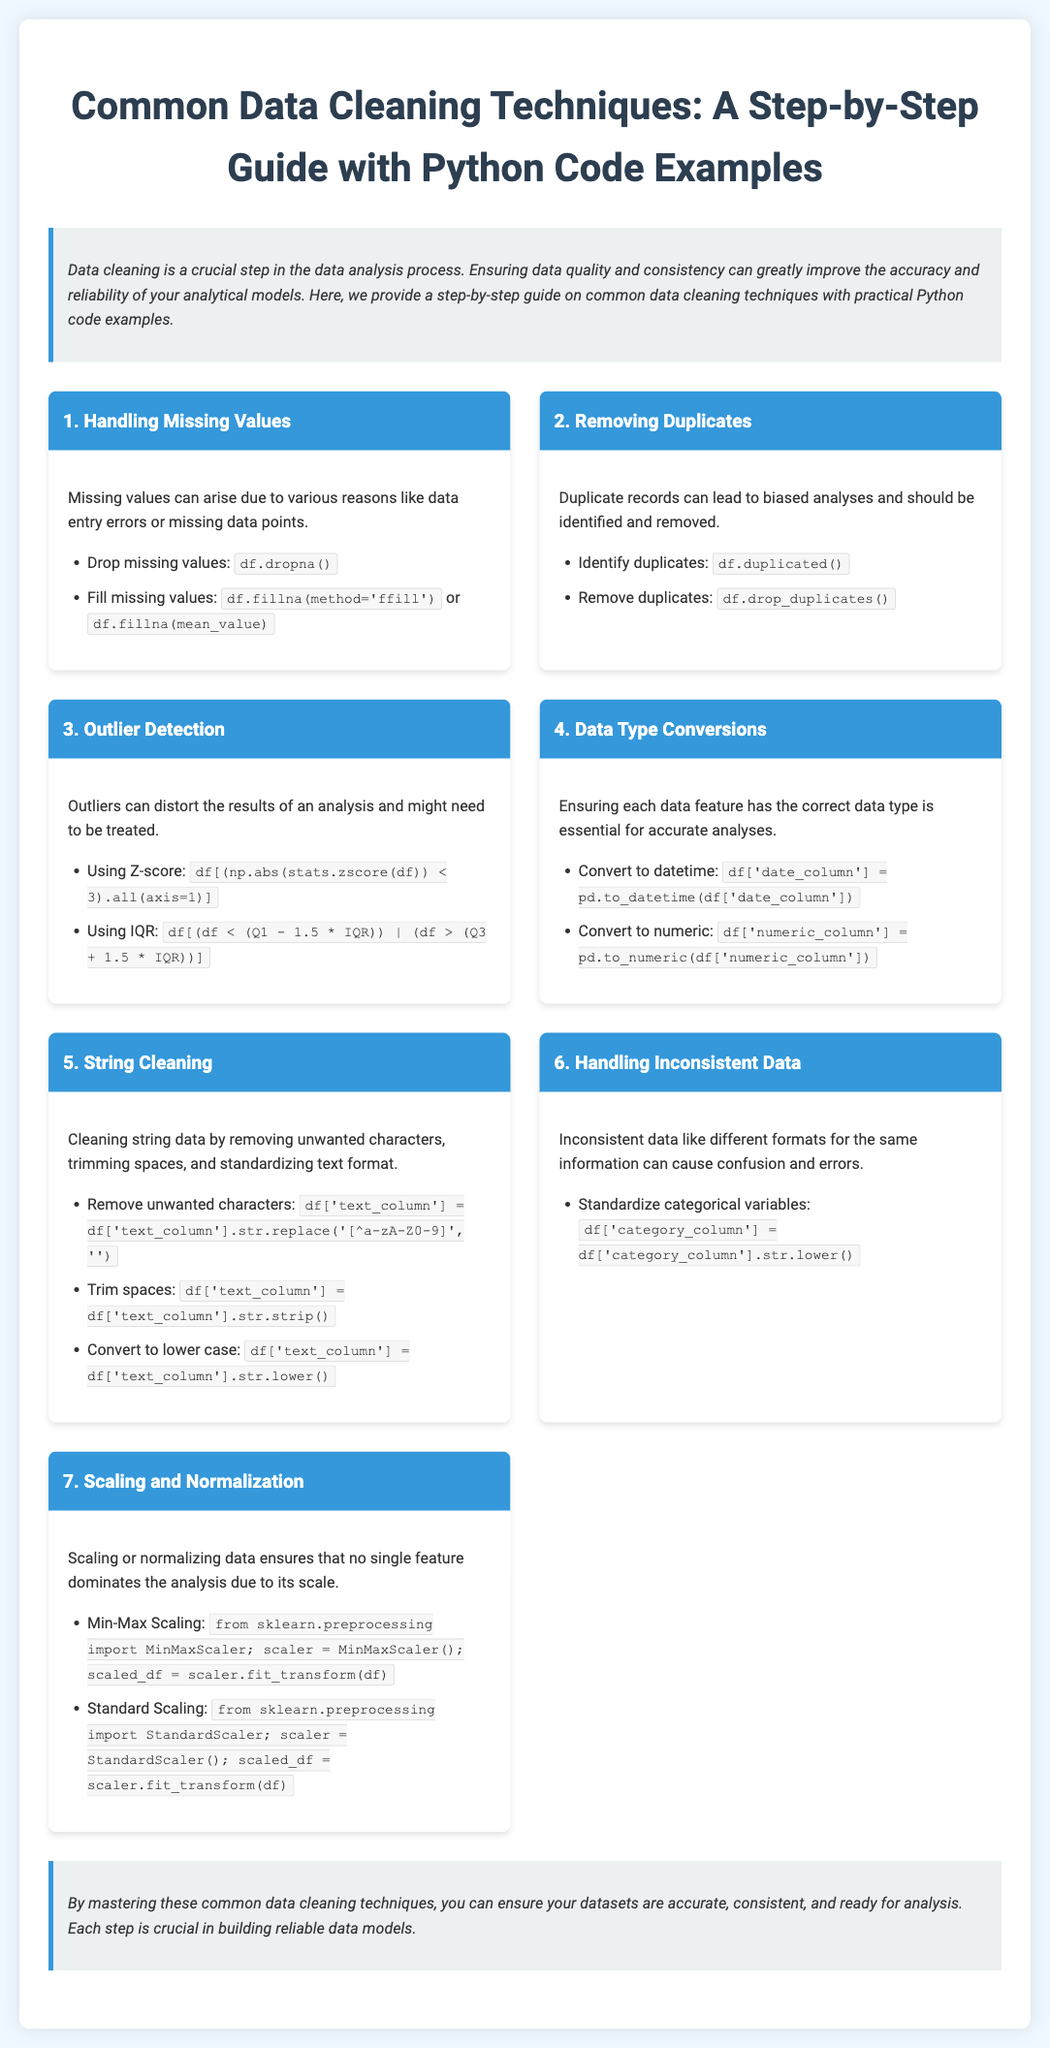What is the title of the infographic? The title of the infographic is located at the top section and describes the main subject of the document.
Answer: Common Data Cleaning Techniques: A Step-by-Step Guide with Python Code Examples How many steps are listed for data cleaning techniques? The number of steps can be counted from the sections outlined in the infographic, showing distinct cleaning techniques.
Answer: Seven What is the first technique mentioned for data cleaning? The first technique is listed in the introductory steps of the infographic, highlighting the common issues in datasets.
Answer: Handling Missing Values What Python function is used to fill missing values? The specific function used for filling missing values is outlined in the steps and can be identified in related subpoints.
Answer: fillna Which technique involves removing duplicates? This technique is specifically mentioned in the document focusing on unique data entries in datasets.
Answer: Removing Duplicates What type of scaling is mentioned besides Min-Max Scaling? The document lists different scaling methods, and this particular one is highlighted alongside another method for normalization.
Answer: Standard Scaling What is stated about handling inconsistent data? The related information points out challenges and ways to standardize data to handle inconsistencies effectively.
Answer: Standardize categorical variables Which library is referred to for scaling data? The library mentioned is recognized within the context of importing to provide scaling options for datasets.
Answer: scikit-learn 